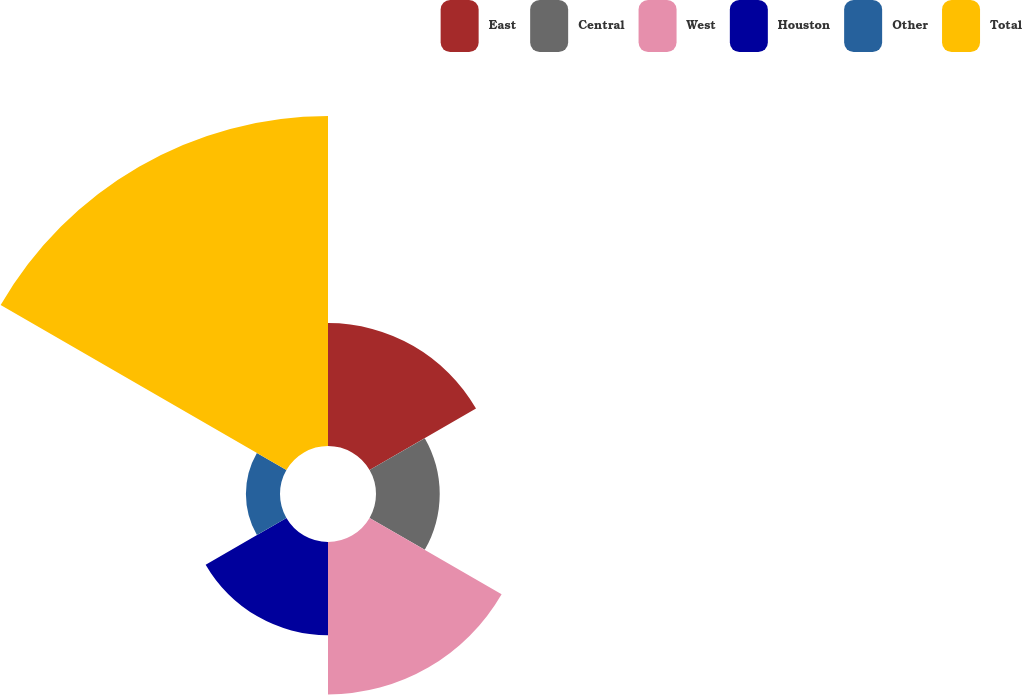Convert chart to OTSL. <chart><loc_0><loc_0><loc_500><loc_500><pie_chart><fcel>East<fcel>Central<fcel>West<fcel>Houston<fcel>Other<fcel>Total<nl><fcel>15.43%<fcel>8.0%<fcel>19.14%<fcel>11.71%<fcel>4.28%<fcel>41.43%<nl></chart> 